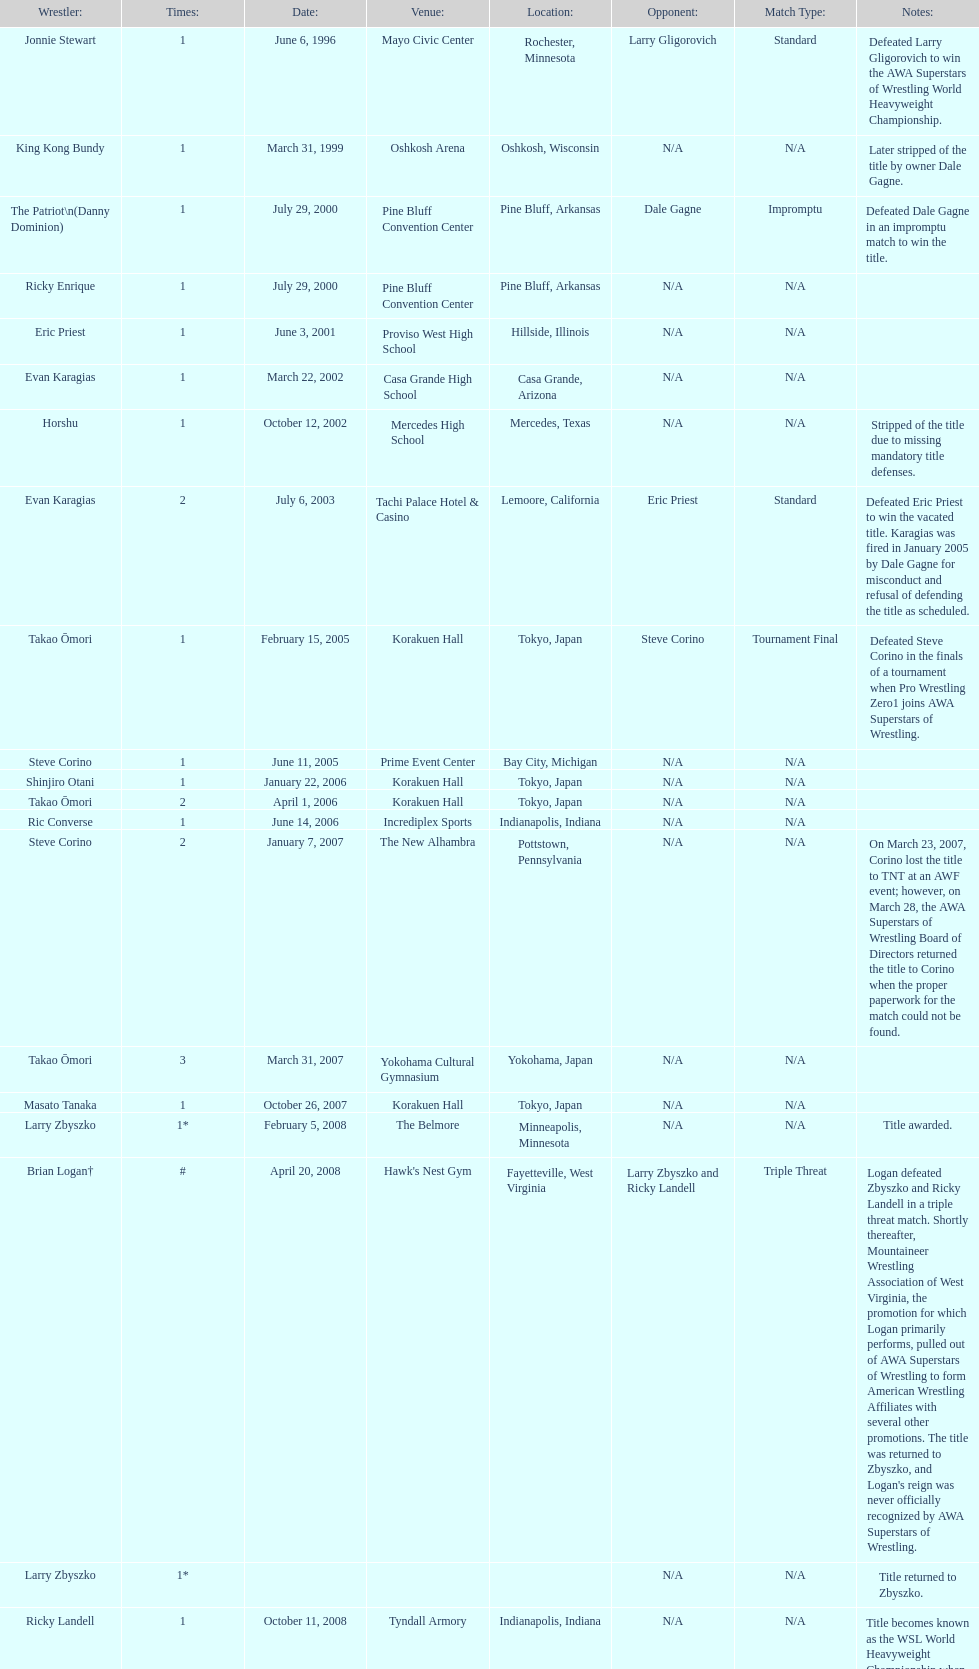Can you give me this table as a dict? {'header': ['Wrestler:', 'Times:', 'Date:', 'Venue:', 'Location:', 'Opponent:', 'Match Type:', 'Notes:'], 'rows': [['Jonnie Stewart', '1', 'June 6, 1996', 'Mayo Civic Center', 'Rochester, Minnesota', 'Larry Gligorovich', 'Standard', 'Defeated Larry Gligorovich to win the AWA Superstars of Wrestling World Heavyweight Championship.'], ['King Kong Bundy', '1', 'March 31, 1999', 'Oshkosh Arena', 'Oshkosh, Wisconsin', 'N/A', 'N/A', 'Later stripped of the title by owner Dale Gagne.'], ['The Patriot\\n(Danny Dominion)', '1', 'July 29, 2000', 'Pine Bluff Convention Center', 'Pine Bluff, Arkansas', 'Dale Gagne', 'Impromptu', 'Defeated Dale Gagne in an impromptu match to win the title.'], ['Ricky Enrique', '1', 'July 29, 2000', 'Pine Bluff Convention Center', 'Pine Bluff, Arkansas', 'N/A', 'N/A', ''], ['Eric Priest', '1', 'June 3, 2001', 'Proviso West High School', 'Hillside, Illinois', 'N/A', 'N/A', ''], ['Evan Karagias', '1', 'March 22, 2002', 'Casa Grande High School', 'Casa Grande, Arizona', 'N/A', 'N/A', ''], ['Horshu', '1', 'October 12, 2002', 'Mercedes High School', 'Mercedes, Texas', 'N/A', 'N/A', 'Stripped of the title due to missing mandatory title defenses.'], ['Evan Karagias', '2', 'July 6, 2003', 'Tachi Palace Hotel & Casino', 'Lemoore, California', 'Eric Priest', 'Standard', 'Defeated Eric Priest to win the vacated title. Karagias was fired in January 2005 by Dale Gagne for misconduct and refusal of defending the title as scheduled.'], ['Takao Ōmori', '1', 'February 15, 2005', 'Korakuen Hall', 'Tokyo, Japan', 'Steve Corino', 'Tournament Final', 'Defeated Steve Corino in the finals of a tournament when Pro Wrestling Zero1 joins AWA Superstars of Wrestling.'], ['Steve Corino', '1', 'June 11, 2005', 'Prime Event Center', 'Bay City, Michigan', 'N/A', 'N/A', ''], ['Shinjiro Otani', '1', 'January 22, 2006', 'Korakuen Hall', 'Tokyo, Japan', 'N/A', 'N/A', ''], ['Takao Ōmori', '2', 'April 1, 2006', 'Korakuen Hall', 'Tokyo, Japan', 'N/A', 'N/A', ''], ['Ric Converse', '1', 'June 14, 2006', 'Incrediplex Sports', 'Indianapolis, Indiana', 'N/A', 'N/A', ''], ['Steve Corino', '2', 'January 7, 2007', 'The New Alhambra', 'Pottstown, Pennsylvania', 'N/A', 'N/A', 'On March 23, 2007, Corino lost the title to TNT at an AWF event; however, on March 28, the AWA Superstars of Wrestling Board of Directors returned the title to Corino when the proper paperwork for the match could not be found.'], ['Takao Ōmori', '3', 'March 31, 2007', 'Yokohama Cultural Gymnasium', 'Yokohama, Japan', 'N/A', 'N/A', ''], ['Masato Tanaka', '1', 'October 26, 2007', 'Korakuen Hall', 'Tokyo, Japan', 'N/A', 'N/A', ''], ['Larry Zbyszko', '1*', 'February 5, 2008', 'The Belmore', 'Minneapolis, Minnesota', 'N/A', 'N/A', 'Title awarded.'], ['Brian Logan†', '#', 'April 20, 2008', "Hawk's Nest Gym", 'Fayetteville, West Virginia', 'Larry Zbyszko and Ricky Landell', 'Triple Threat', "Logan defeated Zbyszko and Ricky Landell in a triple threat match. Shortly thereafter, Mountaineer Wrestling Association of West Virginia, the promotion for which Logan primarily performs, pulled out of AWA Superstars of Wrestling to form American Wrestling Affiliates with several other promotions. The title was returned to Zbyszko, and Logan's reign was never officially recognized by AWA Superstars of Wrestling."], ['Larry Zbyszko', '1*', '', '', '', 'N/A', 'N/A', 'Title returned to Zbyszko.'], ['Ricky Landell', '1', 'October 11, 2008', 'Tyndall Armory', 'Indianapolis, Indiana', 'N/A', 'N/A', 'Title becomes known as the WSL World Heavyweight Championship when the promotion is forced to rename.'], ['Keith Walker', '1', 'February 21, 2009', 'Eastport Elementary School Gym', 'Michigan City, Indiana', 'N/A', 'N/A', ''], ['Jonnie Stewart', '2', 'June 9, 2012', "Prince George's Stadium", 'Landover, Maryland', 'Keith Walker and Ricky Landell', 'Controversial', "In a day referred to as The Saturday Night Massacre, in reference to President Nixon's firing of two Whitehouse attorneys general in one night; President Dale Gagne strips and fires Keith Walker when Walker refuses to defend the title against Ricky Landell, in an event in Landover, Maryland. When Landell is awarded the title, he refuses to accept and is too promptly fired by Gagne, who than awards the title to Jonnie Stewart."], ['The Honky Tonk Man', '1', 'August 18, 2012', 'Tebala Event Center', 'Rockford, Illinois', 'Mike Bally', 'Substitute', "The morning of the event, Jonnie Stewart's doctors declare him PUP (physically unable to perform) and WSL officials agree to let Mike Bally sub for Stewart."]]} Who is the last wrestler to hold the title? The Honky Tonk Man. 